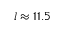Convert formula to latex. <formula><loc_0><loc_0><loc_500><loc_500>l \approx 1 1 . 5</formula> 